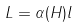<formula> <loc_0><loc_0><loc_500><loc_500>L = \alpha ( H ) l</formula> 